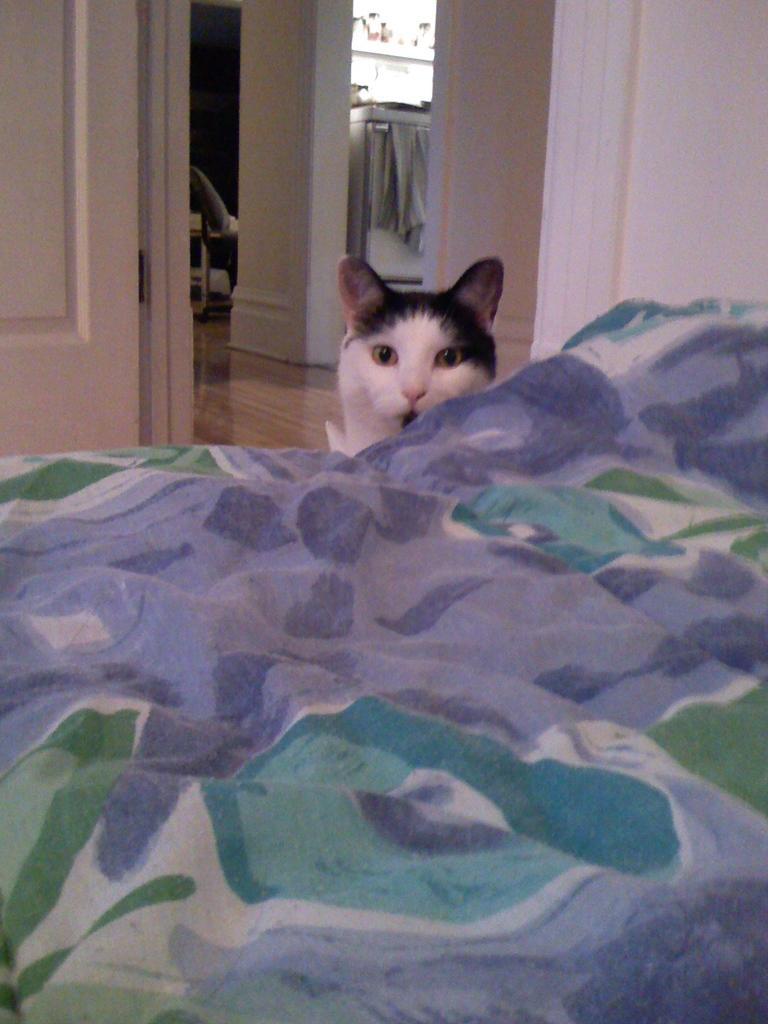Describe this image in one or two sentences. In this image I can see a bed. I can see a cat. In the background, I can see the wall and some object on the floor. 